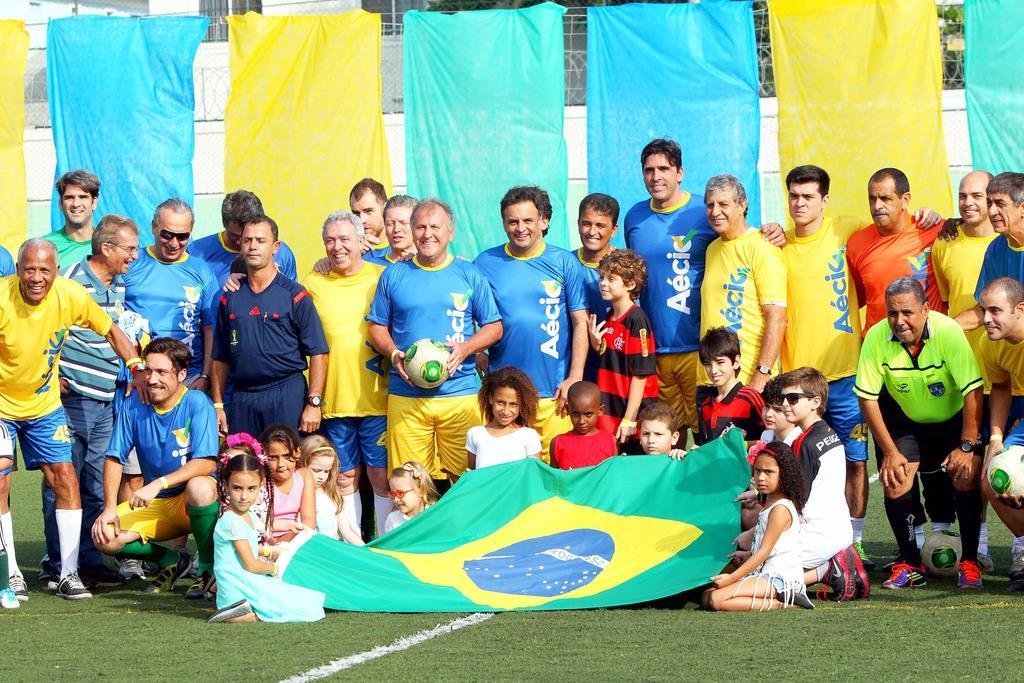Can you describe this image briefly? This picture is taken in the ground, There are some people standing, In the middle there is a man standing and holding a football which is in white color, There are some kids siting on the ground, In the background there are some blue and yellow color clothes. 